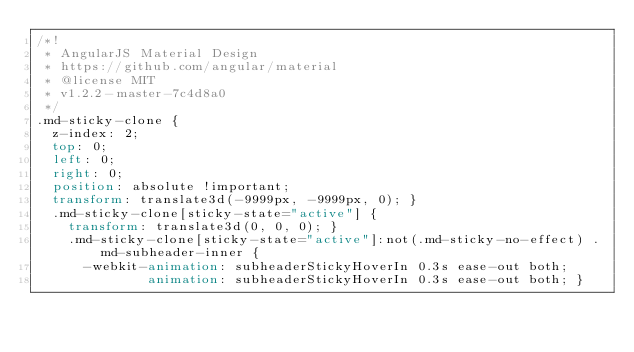<code> <loc_0><loc_0><loc_500><loc_500><_CSS_>/*!
 * AngularJS Material Design
 * https://github.com/angular/material
 * @license MIT
 * v1.2.2-master-7c4d8a0
 */
.md-sticky-clone {
  z-index: 2;
  top: 0;
  left: 0;
  right: 0;
  position: absolute !important;
  transform: translate3d(-9999px, -9999px, 0); }
  .md-sticky-clone[sticky-state="active"] {
    transform: translate3d(0, 0, 0); }
    .md-sticky-clone[sticky-state="active"]:not(.md-sticky-no-effect) .md-subheader-inner {
      -webkit-animation: subheaderStickyHoverIn 0.3s ease-out both;
              animation: subheaderStickyHoverIn 0.3s ease-out both; }
</code> 